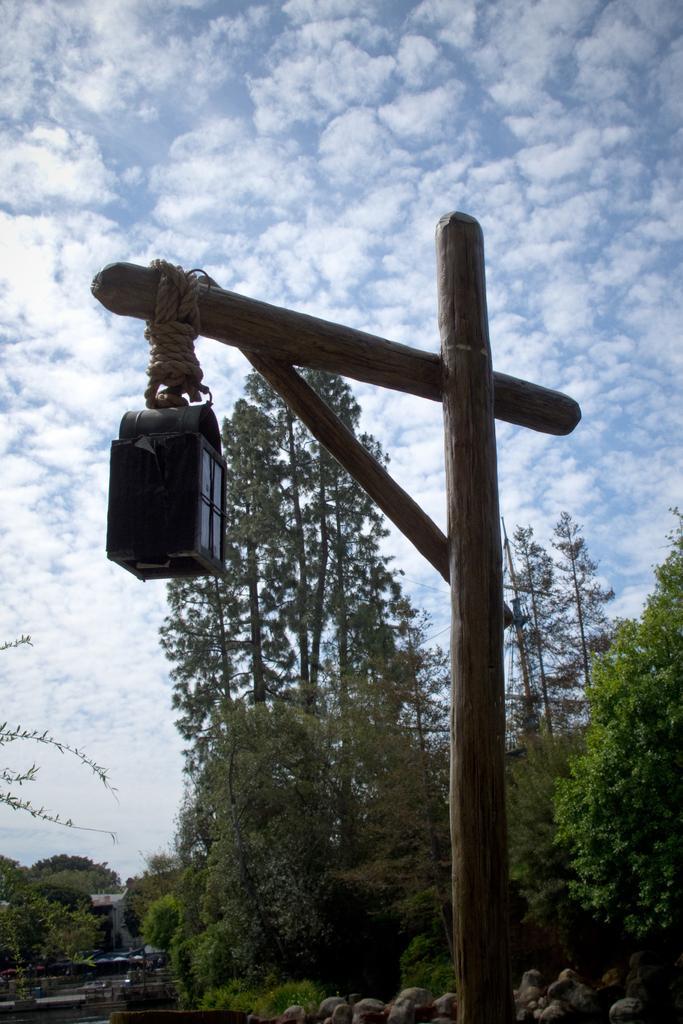Please provide a concise description of this image. In this picture I can see there is a wooden pillar and it has a light attached to it. There are stones, trees and the sky is clear. 